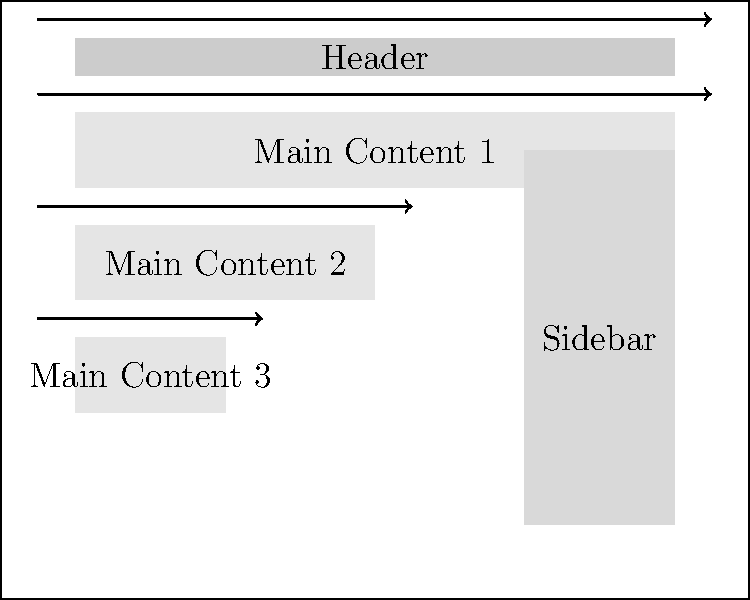In the classic F-pattern layout shown above, which element typically receives the least visual attention from users, and why? To determine which element receives the least visual attention in a classic F-pattern layout, we need to consider the following steps:

1. Understand the F-pattern: Users typically scan web pages in an F-shaped pattern, starting from the top-left corner and moving horizontally, then vertically down the left side.

2. Analyze the layout:
   a. Header: Receives immediate attention as it's at the top.
   b. Main Content 1: Gets high attention as it's directly below the header.
   c. Main Content 2: Receives moderate attention as it's in the second horizontal scan.
   d. Main Content 3: Gets some attention as it's on the left side of the vertical scan.
   e. Sidebar: Located on the right side, away from the primary F-pattern scan path.

3. Consider user behavior: Users tend to focus on the left side of the page and pay less attention to the right side, especially as they move down the page.

4. Evaluate element positions: The sidebar is positioned on the right side and extends below the main content areas, placing it outside the primary F-pattern scan path.

5. Conclusion: The sidebar receives the least visual attention because it's located furthest from the natural F-pattern scanning behavior of users.
Answer: Sidebar 